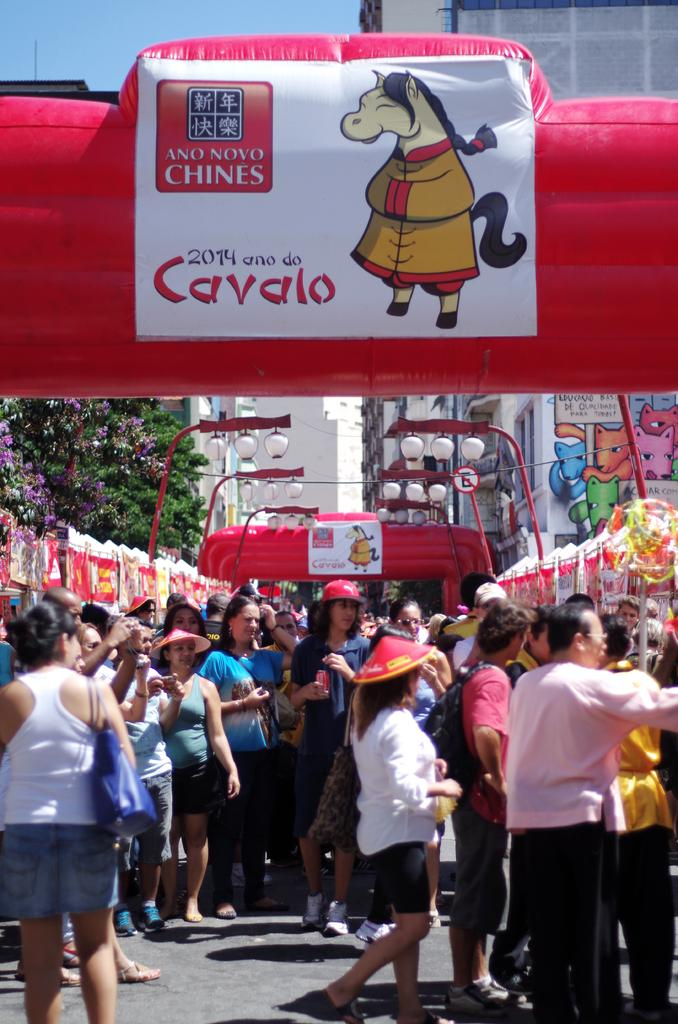What is located at the bottom of the image? There is a group of people at the bottom of the image. What can be seen at the top of the image? There is an air balloon at the top of the image. Is there anything special about the air balloon? Yes, the air balloon has a sticker on it. Can you see a kitty playing with a rod on the air balloon in the image? No, there is no kitty or rod present on the air balloon in the image. 